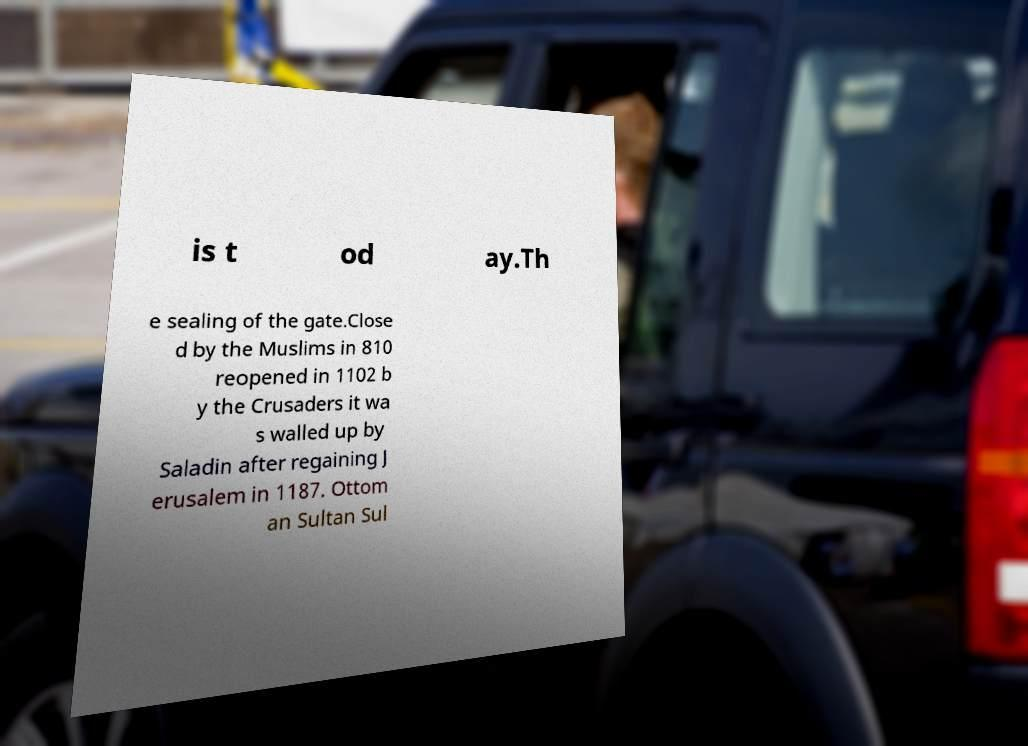There's text embedded in this image that I need extracted. Can you transcribe it verbatim? is t od ay.Th e sealing of the gate.Close d by the Muslims in 810 reopened in 1102 b y the Crusaders it wa s walled up by Saladin after regaining J erusalem in 1187. Ottom an Sultan Sul 